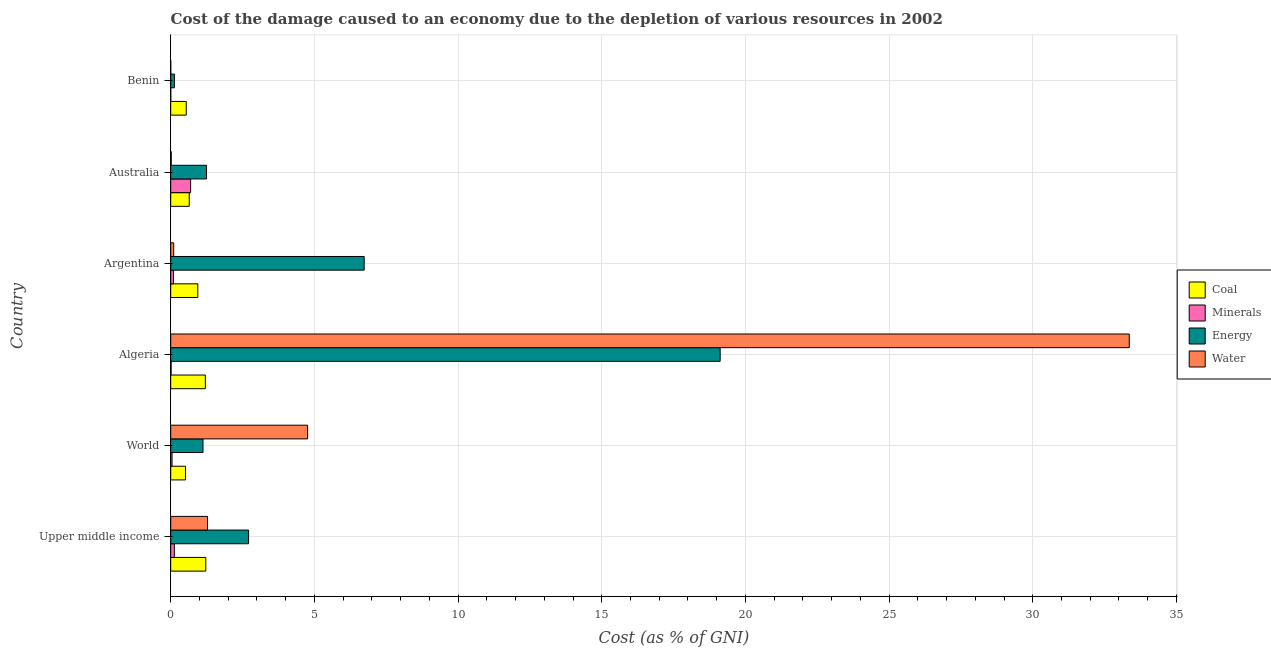Are the number of bars per tick equal to the number of legend labels?
Your answer should be compact. Yes. Are the number of bars on each tick of the Y-axis equal?
Ensure brevity in your answer.  Yes. How many bars are there on the 1st tick from the bottom?
Give a very brief answer. 4. What is the label of the 4th group of bars from the top?
Your response must be concise. Algeria. What is the cost of damage due to depletion of water in World?
Your response must be concise. 4.76. Across all countries, what is the maximum cost of damage due to depletion of water?
Provide a short and direct response. 33.36. Across all countries, what is the minimum cost of damage due to depletion of minerals?
Ensure brevity in your answer.  0. In which country was the cost of damage due to depletion of water maximum?
Keep it short and to the point. Algeria. In which country was the cost of damage due to depletion of coal minimum?
Offer a terse response. World. What is the total cost of damage due to depletion of water in the graph?
Your answer should be very brief. 39.52. What is the difference between the cost of damage due to depletion of coal in Australia and that in Upper middle income?
Make the answer very short. -0.58. What is the difference between the cost of damage due to depletion of energy in World and the cost of damage due to depletion of coal in Algeria?
Your answer should be compact. -0.08. What is the average cost of damage due to depletion of water per country?
Ensure brevity in your answer.  6.59. What is the difference between the cost of damage due to depletion of coal and cost of damage due to depletion of minerals in Benin?
Ensure brevity in your answer.  0.54. What is the ratio of the cost of damage due to depletion of minerals in Algeria to that in Australia?
Make the answer very short. 0.02. Is the cost of damage due to depletion of water in Algeria less than that in Australia?
Keep it short and to the point. No. What is the difference between the highest and the second highest cost of damage due to depletion of minerals?
Your answer should be compact. 0.57. What is the difference between the highest and the lowest cost of damage due to depletion of water?
Your answer should be compact. 33.36. What does the 1st bar from the top in Algeria represents?
Offer a terse response. Water. What does the 2nd bar from the bottom in Upper middle income represents?
Offer a very short reply. Minerals. How many bars are there?
Provide a short and direct response. 24. Are all the bars in the graph horizontal?
Offer a terse response. Yes. What is the difference between two consecutive major ticks on the X-axis?
Offer a terse response. 5. Does the graph contain any zero values?
Your response must be concise. No. What is the title of the graph?
Offer a very short reply. Cost of the damage caused to an economy due to the depletion of various resources in 2002 . What is the label or title of the X-axis?
Your answer should be very brief. Cost (as % of GNI). What is the label or title of the Y-axis?
Keep it short and to the point. Country. What is the Cost (as % of GNI) in Coal in Upper middle income?
Your answer should be very brief. 1.22. What is the Cost (as % of GNI) in Minerals in Upper middle income?
Your response must be concise. 0.13. What is the Cost (as % of GNI) in Energy in Upper middle income?
Give a very brief answer. 2.71. What is the Cost (as % of GNI) of Water in Upper middle income?
Your response must be concise. 1.28. What is the Cost (as % of GNI) in Coal in World?
Your answer should be very brief. 0.52. What is the Cost (as % of GNI) in Minerals in World?
Offer a very short reply. 0.05. What is the Cost (as % of GNI) of Energy in World?
Provide a succinct answer. 1.12. What is the Cost (as % of GNI) of Water in World?
Your answer should be compact. 4.76. What is the Cost (as % of GNI) in Coal in Algeria?
Keep it short and to the point. 1.21. What is the Cost (as % of GNI) of Minerals in Algeria?
Your answer should be very brief. 0.01. What is the Cost (as % of GNI) of Energy in Algeria?
Ensure brevity in your answer.  19.12. What is the Cost (as % of GNI) in Water in Algeria?
Offer a very short reply. 33.36. What is the Cost (as % of GNI) in Coal in Argentina?
Give a very brief answer. 0.94. What is the Cost (as % of GNI) in Minerals in Argentina?
Provide a short and direct response. 0.09. What is the Cost (as % of GNI) of Energy in Argentina?
Your answer should be compact. 6.73. What is the Cost (as % of GNI) in Water in Argentina?
Offer a terse response. 0.1. What is the Cost (as % of GNI) in Coal in Australia?
Your response must be concise. 0.64. What is the Cost (as % of GNI) in Minerals in Australia?
Make the answer very short. 0.69. What is the Cost (as % of GNI) of Energy in Australia?
Provide a succinct answer. 1.25. What is the Cost (as % of GNI) in Water in Australia?
Provide a succinct answer. 0.02. What is the Cost (as % of GNI) of Coal in Benin?
Ensure brevity in your answer.  0.54. What is the Cost (as % of GNI) in Minerals in Benin?
Offer a terse response. 0. What is the Cost (as % of GNI) of Energy in Benin?
Your answer should be compact. 0.13. What is the Cost (as % of GNI) of Water in Benin?
Your response must be concise. 0. Across all countries, what is the maximum Cost (as % of GNI) of Coal?
Provide a succinct answer. 1.22. Across all countries, what is the maximum Cost (as % of GNI) of Minerals?
Ensure brevity in your answer.  0.69. Across all countries, what is the maximum Cost (as % of GNI) of Energy?
Provide a succinct answer. 19.12. Across all countries, what is the maximum Cost (as % of GNI) of Water?
Ensure brevity in your answer.  33.36. Across all countries, what is the minimum Cost (as % of GNI) in Coal?
Offer a terse response. 0.52. Across all countries, what is the minimum Cost (as % of GNI) of Minerals?
Keep it short and to the point. 0. Across all countries, what is the minimum Cost (as % of GNI) in Energy?
Provide a short and direct response. 0.13. Across all countries, what is the minimum Cost (as % of GNI) of Water?
Your response must be concise. 0. What is the total Cost (as % of GNI) of Coal in the graph?
Give a very brief answer. 5.07. What is the total Cost (as % of GNI) of Minerals in the graph?
Keep it short and to the point. 0.98. What is the total Cost (as % of GNI) of Energy in the graph?
Offer a very short reply. 31.06. What is the total Cost (as % of GNI) of Water in the graph?
Provide a short and direct response. 39.52. What is the difference between the Cost (as % of GNI) in Coal in Upper middle income and that in World?
Keep it short and to the point. 0.7. What is the difference between the Cost (as % of GNI) in Minerals in Upper middle income and that in World?
Ensure brevity in your answer.  0.08. What is the difference between the Cost (as % of GNI) in Energy in Upper middle income and that in World?
Ensure brevity in your answer.  1.59. What is the difference between the Cost (as % of GNI) of Water in Upper middle income and that in World?
Your answer should be very brief. -3.48. What is the difference between the Cost (as % of GNI) of Coal in Upper middle income and that in Algeria?
Provide a succinct answer. 0.02. What is the difference between the Cost (as % of GNI) of Minerals in Upper middle income and that in Algeria?
Your answer should be very brief. 0.11. What is the difference between the Cost (as % of GNI) of Energy in Upper middle income and that in Algeria?
Your answer should be compact. -16.41. What is the difference between the Cost (as % of GNI) in Water in Upper middle income and that in Algeria?
Give a very brief answer. -32.08. What is the difference between the Cost (as % of GNI) in Coal in Upper middle income and that in Argentina?
Give a very brief answer. 0.28. What is the difference between the Cost (as % of GNI) in Minerals in Upper middle income and that in Argentina?
Provide a succinct answer. 0.03. What is the difference between the Cost (as % of GNI) in Energy in Upper middle income and that in Argentina?
Ensure brevity in your answer.  -4.02. What is the difference between the Cost (as % of GNI) of Water in Upper middle income and that in Argentina?
Offer a very short reply. 1.18. What is the difference between the Cost (as % of GNI) of Coal in Upper middle income and that in Australia?
Provide a short and direct response. 0.58. What is the difference between the Cost (as % of GNI) of Minerals in Upper middle income and that in Australia?
Provide a succinct answer. -0.57. What is the difference between the Cost (as % of GNI) of Energy in Upper middle income and that in Australia?
Offer a very short reply. 1.46. What is the difference between the Cost (as % of GNI) in Water in Upper middle income and that in Australia?
Your answer should be compact. 1.26. What is the difference between the Cost (as % of GNI) of Coal in Upper middle income and that in Benin?
Provide a succinct answer. 0.68. What is the difference between the Cost (as % of GNI) in Minerals in Upper middle income and that in Benin?
Offer a very short reply. 0.13. What is the difference between the Cost (as % of GNI) in Energy in Upper middle income and that in Benin?
Keep it short and to the point. 2.58. What is the difference between the Cost (as % of GNI) of Water in Upper middle income and that in Benin?
Offer a terse response. 1.28. What is the difference between the Cost (as % of GNI) in Coal in World and that in Algeria?
Offer a terse response. -0.69. What is the difference between the Cost (as % of GNI) in Minerals in World and that in Algeria?
Keep it short and to the point. 0.03. What is the difference between the Cost (as % of GNI) of Energy in World and that in Algeria?
Your answer should be compact. -18. What is the difference between the Cost (as % of GNI) of Water in World and that in Algeria?
Provide a short and direct response. -28.6. What is the difference between the Cost (as % of GNI) in Coal in World and that in Argentina?
Provide a short and direct response. -0.43. What is the difference between the Cost (as % of GNI) in Minerals in World and that in Argentina?
Provide a short and direct response. -0.05. What is the difference between the Cost (as % of GNI) in Energy in World and that in Argentina?
Provide a succinct answer. -5.61. What is the difference between the Cost (as % of GNI) of Water in World and that in Argentina?
Give a very brief answer. 4.66. What is the difference between the Cost (as % of GNI) of Coal in World and that in Australia?
Provide a succinct answer. -0.13. What is the difference between the Cost (as % of GNI) of Minerals in World and that in Australia?
Your answer should be very brief. -0.65. What is the difference between the Cost (as % of GNI) in Energy in World and that in Australia?
Offer a terse response. -0.12. What is the difference between the Cost (as % of GNI) in Water in World and that in Australia?
Your answer should be very brief. 4.75. What is the difference between the Cost (as % of GNI) of Coal in World and that in Benin?
Keep it short and to the point. -0.03. What is the difference between the Cost (as % of GNI) in Minerals in World and that in Benin?
Keep it short and to the point. 0.05. What is the difference between the Cost (as % of GNI) of Water in World and that in Benin?
Offer a very short reply. 4.76. What is the difference between the Cost (as % of GNI) of Coal in Algeria and that in Argentina?
Your answer should be very brief. 0.26. What is the difference between the Cost (as % of GNI) in Minerals in Algeria and that in Argentina?
Ensure brevity in your answer.  -0.08. What is the difference between the Cost (as % of GNI) in Energy in Algeria and that in Argentina?
Offer a very short reply. 12.39. What is the difference between the Cost (as % of GNI) of Water in Algeria and that in Argentina?
Your response must be concise. 33.25. What is the difference between the Cost (as % of GNI) of Coal in Algeria and that in Australia?
Your response must be concise. 0.56. What is the difference between the Cost (as % of GNI) in Minerals in Algeria and that in Australia?
Keep it short and to the point. -0.68. What is the difference between the Cost (as % of GNI) in Energy in Algeria and that in Australia?
Provide a short and direct response. 17.87. What is the difference between the Cost (as % of GNI) in Water in Algeria and that in Australia?
Provide a short and direct response. 33.34. What is the difference between the Cost (as % of GNI) in Coal in Algeria and that in Benin?
Make the answer very short. 0.66. What is the difference between the Cost (as % of GNI) in Minerals in Algeria and that in Benin?
Offer a terse response. 0.01. What is the difference between the Cost (as % of GNI) in Energy in Algeria and that in Benin?
Provide a succinct answer. 18.99. What is the difference between the Cost (as % of GNI) of Water in Algeria and that in Benin?
Offer a very short reply. 33.36. What is the difference between the Cost (as % of GNI) in Coal in Argentina and that in Australia?
Give a very brief answer. 0.3. What is the difference between the Cost (as % of GNI) in Minerals in Argentina and that in Australia?
Give a very brief answer. -0.6. What is the difference between the Cost (as % of GNI) in Energy in Argentina and that in Australia?
Offer a terse response. 5.49. What is the difference between the Cost (as % of GNI) of Water in Argentina and that in Australia?
Your answer should be compact. 0.09. What is the difference between the Cost (as % of GNI) of Coal in Argentina and that in Benin?
Ensure brevity in your answer.  0.4. What is the difference between the Cost (as % of GNI) of Minerals in Argentina and that in Benin?
Offer a very short reply. 0.09. What is the difference between the Cost (as % of GNI) of Energy in Argentina and that in Benin?
Ensure brevity in your answer.  6.6. What is the difference between the Cost (as % of GNI) in Water in Argentina and that in Benin?
Your response must be concise. 0.1. What is the difference between the Cost (as % of GNI) in Coal in Australia and that in Benin?
Give a very brief answer. 0.1. What is the difference between the Cost (as % of GNI) of Minerals in Australia and that in Benin?
Keep it short and to the point. 0.69. What is the difference between the Cost (as % of GNI) in Energy in Australia and that in Benin?
Keep it short and to the point. 1.12. What is the difference between the Cost (as % of GNI) in Water in Australia and that in Benin?
Your response must be concise. 0.02. What is the difference between the Cost (as % of GNI) of Coal in Upper middle income and the Cost (as % of GNI) of Minerals in World?
Your response must be concise. 1.17. What is the difference between the Cost (as % of GNI) of Coal in Upper middle income and the Cost (as % of GNI) of Energy in World?
Your response must be concise. 0.1. What is the difference between the Cost (as % of GNI) in Coal in Upper middle income and the Cost (as % of GNI) in Water in World?
Keep it short and to the point. -3.54. What is the difference between the Cost (as % of GNI) of Minerals in Upper middle income and the Cost (as % of GNI) of Energy in World?
Keep it short and to the point. -1. What is the difference between the Cost (as % of GNI) in Minerals in Upper middle income and the Cost (as % of GNI) in Water in World?
Offer a terse response. -4.64. What is the difference between the Cost (as % of GNI) in Energy in Upper middle income and the Cost (as % of GNI) in Water in World?
Make the answer very short. -2.05. What is the difference between the Cost (as % of GNI) of Coal in Upper middle income and the Cost (as % of GNI) of Minerals in Algeria?
Provide a short and direct response. 1.21. What is the difference between the Cost (as % of GNI) of Coal in Upper middle income and the Cost (as % of GNI) of Energy in Algeria?
Keep it short and to the point. -17.9. What is the difference between the Cost (as % of GNI) of Coal in Upper middle income and the Cost (as % of GNI) of Water in Algeria?
Give a very brief answer. -32.14. What is the difference between the Cost (as % of GNI) in Minerals in Upper middle income and the Cost (as % of GNI) in Energy in Algeria?
Offer a very short reply. -18.99. What is the difference between the Cost (as % of GNI) in Minerals in Upper middle income and the Cost (as % of GNI) in Water in Algeria?
Provide a succinct answer. -33.23. What is the difference between the Cost (as % of GNI) in Energy in Upper middle income and the Cost (as % of GNI) in Water in Algeria?
Provide a succinct answer. -30.65. What is the difference between the Cost (as % of GNI) in Coal in Upper middle income and the Cost (as % of GNI) in Minerals in Argentina?
Make the answer very short. 1.13. What is the difference between the Cost (as % of GNI) in Coal in Upper middle income and the Cost (as % of GNI) in Energy in Argentina?
Make the answer very short. -5.51. What is the difference between the Cost (as % of GNI) of Coal in Upper middle income and the Cost (as % of GNI) of Water in Argentina?
Your answer should be compact. 1.12. What is the difference between the Cost (as % of GNI) in Minerals in Upper middle income and the Cost (as % of GNI) in Energy in Argentina?
Keep it short and to the point. -6.61. What is the difference between the Cost (as % of GNI) in Minerals in Upper middle income and the Cost (as % of GNI) in Water in Argentina?
Give a very brief answer. 0.02. What is the difference between the Cost (as % of GNI) in Energy in Upper middle income and the Cost (as % of GNI) in Water in Argentina?
Your answer should be very brief. 2.61. What is the difference between the Cost (as % of GNI) in Coal in Upper middle income and the Cost (as % of GNI) in Minerals in Australia?
Provide a short and direct response. 0.53. What is the difference between the Cost (as % of GNI) in Coal in Upper middle income and the Cost (as % of GNI) in Energy in Australia?
Offer a very short reply. -0.03. What is the difference between the Cost (as % of GNI) of Coal in Upper middle income and the Cost (as % of GNI) of Water in Australia?
Offer a terse response. 1.2. What is the difference between the Cost (as % of GNI) of Minerals in Upper middle income and the Cost (as % of GNI) of Energy in Australia?
Your answer should be compact. -1.12. What is the difference between the Cost (as % of GNI) of Minerals in Upper middle income and the Cost (as % of GNI) of Water in Australia?
Provide a short and direct response. 0.11. What is the difference between the Cost (as % of GNI) in Energy in Upper middle income and the Cost (as % of GNI) in Water in Australia?
Provide a succinct answer. 2.69. What is the difference between the Cost (as % of GNI) in Coal in Upper middle income and the Cost (as % of GNI) in Minerals in Benin?
Keep it short and to the point. 1.22. What is the difference between the Cost (as % of GNI) of Coal in Upper middle income and the Cost (as % of GNI) of Energy in Benin?
Offer a terse response. 1.09. What is the difference between the Cost (as % of GNI) of Coal in Upper middle income and the Cost (as % of GNI) of Water in Benin?
Your answer should be very brief. 1.22. What is the difference between the Cost (as % of GNI) in Minerals in Upper middle income and the Cost (as % of GNI) in Energy in Benin?
Make the answer very short. -0. What is the difference between the Cost (as % of GNI) of Minerals in Upper middle income and the Cost (as % of GNI) of Water in Benin?
Offer a terse response. 0.13. What is the difference between the Cost (as % of GNI) in Energy in Upper middle income and the Cost (as % of GNI) in Water in Benin?
Keep it short and to the point. 2.71. What is the difference between the Cost (as % of GNI) in Coal in World and the Cost (as % of GNI) in Minerals in Algeria?
Your response must be concise. 0.5. What is the difference between the Cost (as % of GNI) of Coal in World and the Cost (as % of GNI) of Energy in Algeria?
Your response must be concise. -18.61. What is the difference between the Cost (as % of GNI) in Coal in World and the Cost (as % of GNI) in Water in Algeria?
Ensure brevity in your answer.  -32.84. What is the difference between the Cost (as % of GNI) of Minerals in World and the Cost (as % of GNI) of Energy in Algeria?
Your answer should be compact. -19.08. What is the difference between the Cost (as % of GNI) in Minerals in World and the Cost (as % of GNI) in Water in Algeria?
Provide a short and direct response. -33.31. What is the difference between the Cost (as % of GNI) of Energy in World and the Cost (as % of GNI) of Water in Algeria?
Keep it short and to the point. -32.23. What is the difference between the Cost (as % of GNI) in Coal in World and the Cost (as % of GNI) in Minerals in Argentina?
Provide a short and direct response. 0.42. What is the difference between the Cost (as % of GNI) in Coal in World and the Cost (as % of GNI) in Energy in Argentina?
Give a very brief answer. -6.22. What is the difference between the Cost (as % of GNI) of Coal in World and the Cost (as % of GNI) of Water in Argentina?
Provide a short and direct response. 0.41. What is the difference between the Cost (as % of GNI) in Minerals in World and the Cost (as % of GNI) in Energy in Argentina?
Provide a short and direct response. -6.69. What is the difference between the Cost (as % of GNI) of Minerals in World and the Cost (as % of GNI) of Water in Argentina?
Offer a very short reply. -0.06. What is the difference between the Cost (as % of GNI) in Energy in World and the Cost (as % of GNI) in Water in Argentina?
Give a very brief answer. 1.02. What is the difference between the Cost (as % of GNI) of Coal in World and the Cost (as % of GNI) of Minerals in Australia?
Your response must be concise. -0.18. What is the difference between the Cost (as % of GNI) of Coal in World and the Cost (as % of GNI) of Energy in Australia?
Make the answer very short. -0.73. What is the difference between the Cost (as % of GNI) in Coal in World and the Cost (as % of GNI) in Water in Australia?
Offer a terse response. 0.5. What is the difference between the Cost (as % of GNI) of Minerals in World and the Cost (as % of GNI) of Energy in Australia?
Your response must be concise. -1.2. What is the difference between the Cost (as % of GNI) of Minerals in World and the Cost (as % of GNI) of Water in Australia?
Your response must be concise. 0.03. What is the difference between the Cost (as % of GNI) of Energy in World and the Cost (as % of GNI) of Water in Australia?
Provide a succinct answer. 1.11. What is the difference between the Cost (as % of GNI) in Coal in World and the Cost (as % of GNI) in Minerals in Benin?
Offer a terse response. 0.51. What is the difference between the Cost (as % of GNI) in Coal in World and the Cost (as % of GNI) in Energy in Benin?
Make the answer very short. 0.39. What is the difference between the Cost (as % of GNI) in Coal in World and the Cost (as % of GNI) in Water in Benin?
Your answer should be compact. 0.52. What is the difference between the Cost (as % of GNI) in Minerals in World and the Cost (as % of GNI) in Energy in Benin?
Keep it short and to the point. -0.08. What is the difference between the Cost (as % of GNI) in Minerals in World and the Cost (as % of GNI) in Water in Benin?
Ensure brevity in your answer.  0.05. What is the difference between the Cost (as % of GNI) in Energy in World and the Cost (as % of GNI) in Water in Benin?
Provide a short and direct response. 1.12. What is the difference between the Cost (as % of GNI) of Coal in Algeria and the Cost (as % of GNI) of Minerals in Argentina?
Your answer should be very brief. 1.11. What is the difference between the Cost (as % of GNI) of Coal in Algeria and the Cost (as % of GNI) of Energy in Argentina?
Give a very brief answer. -5.53. What is the difference between the Cost (as % of GNI) of Coal in Algeria and the Cost (as % of GNI) of Water in Argentina?
Your response must be concise. 1.1. What is the difference between the Cost (as % of GNI) in Minerals in Algeria and the Cost (as % of GNI) in Energy in Argentina?
Make the answer very short. -6.72. What is the difference between the Cost (as % of GNI) in Minerals in Algeria and the Cost (as % of GNI) in Water in Argentina?
Your response must be concise. -0.09. What is the difference between the Cost (as % of GNI) of Energy in Algeria and the Cost (as % of GNI) of Water in Argentina?
Your answer should be compact. 19.02. What is the difference between the Cost (as % of GNI) in Coal in Algeria and the Cost (as % of GNI) in Minerals in Australia?
Your answer should be compact. 0.51. What is the difference between the Cost (as % of GNI) of Coal in Algeria and the Cost (as % of GNI) of Energy in Australia?
Provide a succinct answer. -0.04. What is the difference between the Cost (as % of GNI) of Coal in Algeria and the Cost (as % of GNI) of Water in Australia?
Make the answer very short. 1.19. What is the difference between the Cost (as % of GNI) of Minerals in Algeria and the Cost (as % of GNI) of Energy in Australia?
Offer a very short reply. -1.23. What is the difference between the Cost (as % of GNI) of Minerals in Algeria and the Cost (as % of GNI) of Water in Australia?
Your answer should be very brief. -0. What is the difference between the Cost (as % of GNI) in Energy in Algeria and the Cost (as % of GNI) in Water in Australia?
Provide a short and direct response. 19.1. What is the difference between the Cost (as % of GNI) of Coal in Algeria and the Cost (as % of GNI) of Minerals in Benin?
Provide a short and direct response. 1.2. What is the difference between the Cost (as % of GNI) of Coal in Algeria and the Cost (as % of GNI) of Energy in Benin?
Give a very brief answer. 1.08. What is the difference between the Cost (as % of GNI) of Coal in Algeria and the Cost (as % of GNI) of Water in Benin?
Offer a terse response. 1.21. What is the difference between the Cost (as % of GNI) of Minerals in Algeria and the Cost (as % of GNI) of Energy in Benin?
Give a very brief answer. -0.12. What is the difference between the Cost (as % of GNI) in Minerals in Algeria and the Cost (as % of GNI) in Water in Benin?
Provide a succinct answer. 0.01. What is the difference between the Cost (as % of GNI) in Energy in Algeria and the Cost (as % of GNI) in Water in Benin?
Your response must be concise. 19.12. What is the difference between the Cost (as % of GNI) of Coal in Argentina and the Cost (as % of GNI) of Minerals in Australia?
Offer a terse response. 0.25. What is the difference between the Cost (as % of GNI) in Coal in Argentina and the Cost (as % of GNI) in Energy in Australia?
Your response must be concise. -0.3. What is the difference between the Cost (as % of GNI) of Coal in Argentina and the Cost (as % of GNI) of Water in Australia?
Ensure brevity in your answer.  0.92. What is the difference between the Cost (as % of GNI) in Minerals in Argentina and the Cost (as % of GNI) in Energy in Australia?
Give a very brief answer. -1.15. What is the difference between the Cost (as % of GNI) of Minerals in Argentina and the Cost (as % of GNI) of Water in Australia?
Ensure brevity in your answer.  0.08. What is the difference between the Cost (as % of GNI) in Energy in Argentina and the Cost (as % of GNI) in Water in Australia?
Your answer should be very brief. 6.71. What is the difference between the Cost (as % of GNI) of Coal in Argentina and the Cost (as % of GNI) of Minerals in Benin?
Ensure brevity in your answer.  0.94. What is the difference between the Cost (as % of GNI) in Coal in Argentina and the Cost (as % of GNI) in Energy in Benin?
Your response must be concise. 0.81. What is the difference between the Cost (as % of GNI) in Coal in Argentina and the Cost (as % of GNI) in Water in Benin?
Offer a very short reply. 0.94. What is the difference between the Cost (as % of GNI) of Minerals in Argentina and the Cost (as % of GNI) of Energy in Benin?
Give a very brief answer. -0.03. What is the difference between the Cost (as % of GNI) of Minerals in Argentina and the Cost (as % of GNI) of Water in Benin?
Offer a very short reply. 0.09. What is the difference between the Cost (as % of GNI) of Energy in Argentina and the Cost (as % of GNI) of Water in Benin?
Offer a very short reply. 6.73. What is the difference between the Cost (as % of GNI) of Coal in Australia and the Cost (as % of GNI) of Minerals in Benin?
Offer a terse response. 0.64. What is the difference between the Cost (as % of GNI) of Coal in Australia and the Cost (as % of GNI) of Energy in Benin?
Provide a succinct answer. 0.51. What is the difference between the Cost (as % of GNI) of Coal in Australia and the Cost (as % of GNI) of Water in Benin?
Provide a succinct answer. 0.64. What is the difference between the Cost (as % of GNI) of Minerals in Australia and the Cost (as % of GNI) of Energy in Benin?
Keep it short and to the point. 0.56. What is the difference between the Cost (as % of GNI) in Minerals in Australia and the Cost (as % of GNI) in Water in Benin?
Make the answer very short. 0.69. What is the difference between the Cost (as % of GNI) in Energy in Australia and the Cost (as % of GNI) in Water in Benin?
Make the answer very short. 1.25. What is the average Cost (as % of GNI) in Coal per country?
Offer a very short reply. 0.84. What is the average Cost (as % of GNI) in Minerals per country?
Ensure brevity in your answer.  0.16. What is the average Cost (as % of GNI) in Energy per country?
Keep it short and to the point. 5.18. What is the average Cost (as % of GNI) of Water per country?
Keep it short and to the point. 6.59. What is the difference between the Cost (as % of GNI) of Coal and Cost (as % of GNI) of Minerals in Upper middle income?
Provide a short and direct response. 1.09. What is the difference between the Cost (as % of GNI) in Coal and Cost (as % of GNI) in Energy in Upper middle income?
Ensure brevity in your answer.  -1.49. What is the difference between the Cost (as % of GNI) of Coal and Cost (as % of GNI) of Water in Upper middle income?
Give a very brief answer. -0.06. What is the difference between the Cost (as % of GNI) in Minerals and Cost (as % of GNI) in Energy in Upper middle income?
Provide a short and direct response. -2.58. What is the difference between the Cost (as % of GNI) of Minerals and Cost (as % of GNI) of Water in Upper middle income?
Offer a very short reply. -1.16. What is the difference between the Cost (as % of GNI) in Energy and Cost (as % of GNI) in Water in Upper middle income?
Your response must be concise. 1.43. What is the difference between the Cost (as % of GNI) in Coal and Cost (as % of GNI) in Minerals in World?
Provide a short and direct response. 0.47. What is the difference between the Cost (as % of GNI) of Coal and Cost (as % of GNI) of Energy in World?
Keep it short and to the point. -0.61. What is the difference between the Cost (as % of GNI) in Coal and Cost (as % of GNI) in Water in World?
Make the answer very short. -4.25. What is the difference between the Cost (as % of GNI) in Minerals and Cost (as % of GNI) in Energy in World?
Provide a succinct answer. -1.08. What is the difference between the Cost (as % of GNI) of Minerals and Cost (as % of GNI) of Water in World?
Provide a short and direct response. -4.72. What is the difference between the Cost (as % of GNI) of Energy and Cost (as % of GNI) of Water in World?
Give a very brief answer. -3.64. What is the difference between the Cost (as % of GNI) of Coal and Cost (as % of GNI) of Minerals in Algeria?
Provide a succinct answer. 1.19. What is the difference between the Cost (as % of GNI) in Coal and Cost (as % of GNI) in Energy in Algeria?
Give a very brief answer. -17.92. What is the difference between the Cost (as % of GNI) in Coal and Cost (as % of GNI) in Water in Algeria?
Your response must be concise. -32.15. What is the difference between the Cost (as % of GNI) of Minerals and Cost (as % of GNI) of Energy in Algeria?
Offer a terse response. -19.11. What is the difference between the Cost (as % of GNI) in Minerals and Cost (as % of GNI) in Water in Algeria?
Provide a succinct answer. -33.34. What is the difference between the Cost (as % of GNI) of Energy and Cost (as % of GNI) of Water in Algeria?
Your answer should be compact. -14.24. What is the difference between the Cost (as % of GNI) of Coal and Cost (as % of GNI) of Minerals in Argentina?
Keep it short and to the point. 0.85. What is the difference between the Cost (as % of GNI) of Coal and Cost (as % of GNI) of Energy in Argentina?
Your answer should be compact. -5.79. What is the difference between the Cost (as % of GNI) of Coal and Cost (as % of GNI) of Water in Argentina?
Your answer should be very brief. 0.84. What is the difference between the Cost (as % of GNI) of Minerals and Cost (as % of GNI) of Energy in Argentina?
Offer a very short reply. -6.64. What is the difference between the Cost (as % of GNI) of Minerals and Cost (as % of GNI) of Water in Argentina?
Make the answer very short. -0.01. What is the difference between the Cost (as % of GNI) in Energy and Cost (as % of GNI) in Water in Argentina?
Your response must be concise. 6.63. What is the difference between the Cost (as % of GNI) of Coal and Cost (as % of GNI) of Minerals in Australia?
Ensure brevity in your answer.  -0.05. What is the difference between the Cost (as % of GNI) of Coal and Cost (as % of GNI) of Energy in Australia?
Ensure brevity in your answer.  -0.6. What is the difference between the Cost (as % of GNI) in Coal and Cost (as % of GNI) in Water in Australia?
Offer a very short reply. 0.63. What is the difference between the Cost (as % of GNI) in Minerals and Cost (as % of GNI) in Energy in Australia?
Your answer should be very brief. -0.55. What is the difference between the Cost (as % of GNI) in Minerals and Cost (as % of GNI) in Water in Australia?
Give a very brief answer. 0.68. What is the difference between the Cost (as % of GNI) of Energy and Cost (as % of GNI) of Water in Australia?
Your answer should be compact. 1.23. What is the difference between the Cost (as % of GNI) in Coal and Cost (as % of GNI) in Minerals in Benin?
Provide a succinct answer. 0.54. What is the difference between the Cost (as % of GNI) of Coal and Cost (as % of GNI) of Energy in Benin?
Make the answer very short. 0.41. What is the difference between the Cost (as % of GNI) in Coal and Cost (as % of GNI) in Water in Benin?
Give a very brief answer. 0.54. What is the difference between the Cost (as % of GNI) in Minerals and Cost (as % of GNI) in Energy in Benin?
Your answer should be very brief. -0.13. What is the difference between the Cost (as % of GNI) in Minerals and Cost (as % of GNI) in Water in Benin?
Offer a very short reply. 0. What is the difference between the Cost (as % of GNI) of Energy and Cost (as % of GNI) of Water in Benin?
Provide a short and direct response. 0.13. What is the ratio of the Cost (as % of GNI) in Coal in Upper middle income to that in World?
Make the answer very short. 2.37. What is the ratio of the Cost (as % of GNI) of Minerals in Upper middle income to that in World?
Your response must be concise. 2.74. What is the ratio of the Cost (as % of GNI) of Energy in Upper middle income to that in World?
Offer a very short reply. 2.41. What is the ratio of the Cost (as % of GNI) of Water in Upper middle income to that in World?
Offer a very short reply. 0.27. What is the ratio of the Cost (as % of GNI) of Coal in Upper middle income to that in Algeria?
Give a very brief answer. 1.01. What is the ratio of the Cost (as % of GNI) in Minerals in Upper middle income to that in Algeria?
Your answer should be very brief. 8.78. What is the ratio of the Cost (as % of GNI) in Energy in Upper middle income to that in Algeria?
Your answer should be very brief. 0.14. What is the ratio of the Cost (as % of GNI) of Water in Upper middle income to that in Algeria?
Your response must be concise. 0.04. What is the ratio of the Cost (as % of GNI) in Coal in Upper middle income to that in Argentina?
Keep it short and to the point. 1.29. What is the ratio of the Cost (as % of GNI) of Energy in Upper middle income to that in Argentina?
Your response must be concise. 0.4. What is the ratio of the Cost (as % of GNI) of Water in Upper middle income to that in Argentina?
Give a very brief answer. 12.35. What is the ratio of the Cost (as % of GNI) in Coal in Upper middle income to that in Australia?
Offer a very short reply. 1.89. What is the ratio of the Cost (as % of GNI) in Minerals in Upper middle income to that in Australia?
Your answer should be very brief. 0.18. What is the ratio of the Cost (as % of GNI) in Energy in Upper middle income to that in Australia?
Offer a terse response. 2.17. What is the ratio of the Cost (as % of GNI) in Water in Upper middle income to that in Australia?
Keep it short and to the point. 71.19. What is the ratio of the Cost (as % of GNI) of Coal in Upper middle income to that in Benin?
Your answer should be very brief. 2.26. What is the ratio of the Cost (as % of GNI) of Minerals in Upper middle income to that in Benin?
Offer a very short reply. 118.74. What is the ratio of the Cost (as % of GNI) in Energy in Upper middle income to that in Benin?
Your answer should be compact. 20.89. What is the ratio of the Cost (as % of GNI) in Water in Upper middle income to that in Benin?
Offer a terse response. 9412.84. What is the ratio of the Cost (as % of GNI) in Coal in World to that in Algeria?
Offer a terse response. 0.43. What is the ratio of the Cost (as % of GNI) in Minerals in World to that in Algeria?
Offer a terse response. 3.2. What is the ratio of the Cost (as % of GNI) in Energy in World to that in Algeria?
Ensure brevity in your answer.  0.06. What is the ratio of the Cost (as % of GNI) of Water in World to that in Algeria?
Give a very brief answer. 0.14. What is the ratio of the Cost (as % of GNI) of Coal in World to that in Argentina?
Give a very brief answer. 0.55. What is the ratio of the Cost (as % of GNI) in Minerals in World to that in Argentina?
Ensure brevity in your answer.  0.49. What is the ratio of the Cost (as % of GNI) in Energy in World to that in Argentina?
Your response must be concise. 0.17. What is the ratio of the Cost (as % of GNI) of Water in World to that in Argentina?
Your answer should be very brief. 45.91. What is the ratio of the Cost (as % of GNI) in Coal in World to that in Australia?
Provide a succinct answer. 0.8. What is the ratio of the Cost (as % of GNI) in Minerals in World to that in Australia?
Provide a succinct answer. 0.07. What is the ratio of the Cost (as % of GNI) in Energy in World to that in Australia?
Keep it short and to the point. 0.9. What is the ratio of the Cost (as % of GNI) in Water in World to that in Australia?
Provide a short and direct response. 264.62. What is the ratio of the Cost (as % of GNI) of Coal in World to that in Benin?
Provide a short and direct response. 0.95. What is the ratio of the Cost (as % of GNI) of Minerals in World to that in Benin?
Offer a terse response. 43.35. What is the ratio of the Cost (as % of GNI) of Energy in World to that in Benin?
Ensure brevity in your answer.  8.66. What is the ratio of the Cost (as % of GNI) in Water in World to that in Benin?
Your response must be concise. 3.50e+04. What is the ratio of the Cost (as % of GNI) of Coal in Algeria to that in Argentina?
Provide a short and direct response. 1.28. What is the ratio of the Cost (as % of GNI) in Minerals in Algeria to that in Argentina?
Your response must be concise. 0.15. What is the ratio of the Cost (as % of GNI) of Energy in Algeria to that in Argentina?
Your answer should be very brief. 2.84. What is the ratio of the Cost (as % of GNI) of Water in Algeria to that in Argentina?
Provide a succinct answer. 321.51. What is the ratio of the Cost (as % of GNI) in Coal in Algeria to that in Australia?
Give a very brief answer. 1.87. What is the ratio of the Cost (as % of GNI) in Minerals in Algeria to that in Australia?
Make the answer very short. 0.02. What is the ratio of the Cost (as % of GNI) in Energy in Algeria to that in Australia?
Your response must be concise. 15.34. What is the ratio of the Cost (as % of GNI) of Water in Algeria to that in Australia?
Your answer should be very brief. 1853.25. What is the ratio of the Cost (as % of GNI) in Coal in Algeria to that in Benin?
Keep it short and to the point. 2.23. What is the ratio of the Cost (as % of GNI) in Minerals in Algeria to that in Benin?
Provide a short and direct response. 13.53. What is the ratio of the Cost (as % of GNI) of Energy in Algeria to that in Benin?
Offer a terse response. 147.42. What is the ratio of the Cost (as % of GNI) in Water in Algeria to that in Benin?
Keep it short and to the point. 2.45e+05. What is the ratio of the Cost (as % of GNI) in Coal in Argentina to that in Australia?
Your response must be concise. 1.46. What is the ratio of the Cost (as % of GNI) in Minerals in Argentina to that in Australia?
Ensure brevity in your answer.  0.14. What is the ratio of the Cost (as % of GNI) of Energy in Argentina to that in Australia?
Your response must be concise. 5.4. What is the ratio of the Cost (as % of GNI) in Water in Argentina to that in Australia?
Your response must be concise. 5.76. What is the ratio of the Cost (as % of GNI) of Coal in Argentina to that in Benin?
Give a very brief answer. 1.74. What is the ratio of the Cost (as % of GNI) of Minerals in Argentina to that in Benin?
Provide a succinct answer. 89.05. What is the ratio of the Cost (as % of GNI) of Energy in Argentina to that in Benin?
Give a very brief answer. 51.91. What is the ratio of the Cost (as % of GNI) of Water in Argentina to that in Benin?
Your response must be concise. 762.17. What is the ratio of the Cost (as % of GNI) in Coal in Australia to that in Benin?
Ensure brevity in your answer.  1.19. What is the ratio of the Cost (as % of GNI) of Minerals in Australia to that in Benin?
Offer a terse response. 651.31. What is the ratio of the Cost (as % of GNI) in Energy in Australia to that in Benin?
Make the answer very short. 9.61. What is the ratio of the Cost (as % of GNI) in Water in Australia to that in Benin?
Offer a very short reply. 132.23. What is the difference between the highest and the second highest Cost (as % of GNI) of Coal?
Give a very brief answer. 0.02. What is the difference between the highest and the second highest Cost (as % of GNI) of Minerals?
Your answer should be compact. 0.57. What is the difference between the highest and the second highest Cost (as % of GNI) of Energy?
Keep it short and to the point. 12.39. What is the difference between the highest and the second highest Cost (as % of GNI) of Water?
Your response must be concise. 28.6. What is the difference between the highest and the lowest Cost (as % of GNI) in Coal?
Provide a succinct answer. 0.7. What is the difference between the highest and the lowest Cost (as % of GNI) of Minerals?
Ensure brevity in your answer.  0.69. What is the difference between the highest and the lowest Cost (as % of GNI) in Energy?
Keep it short and to the point. 18.99. What is the difference between the highest and the lowest Cost (as % of GNI) of Water?
Your answer should be compact. 33.36. 